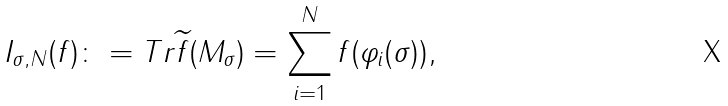Convert formula to latex. <formula><loc_0><loc_0><loc_500><loc_500>I _ { \sigma , N } ( f ) \colon = T r \widetilde { f } ( M _ { \sigma } ) = \sum _ { i = 1 } ^ { N } f ( \varphi _ { i } ( \sigma ) ) ,</formula> 